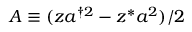<formula> <loc_0><loc_0><loc_500><loc_500>A \equiv ( z a ^ { \dagger 2 } - z ^ { * } a ^ { 2 } ) / 2</formula> 